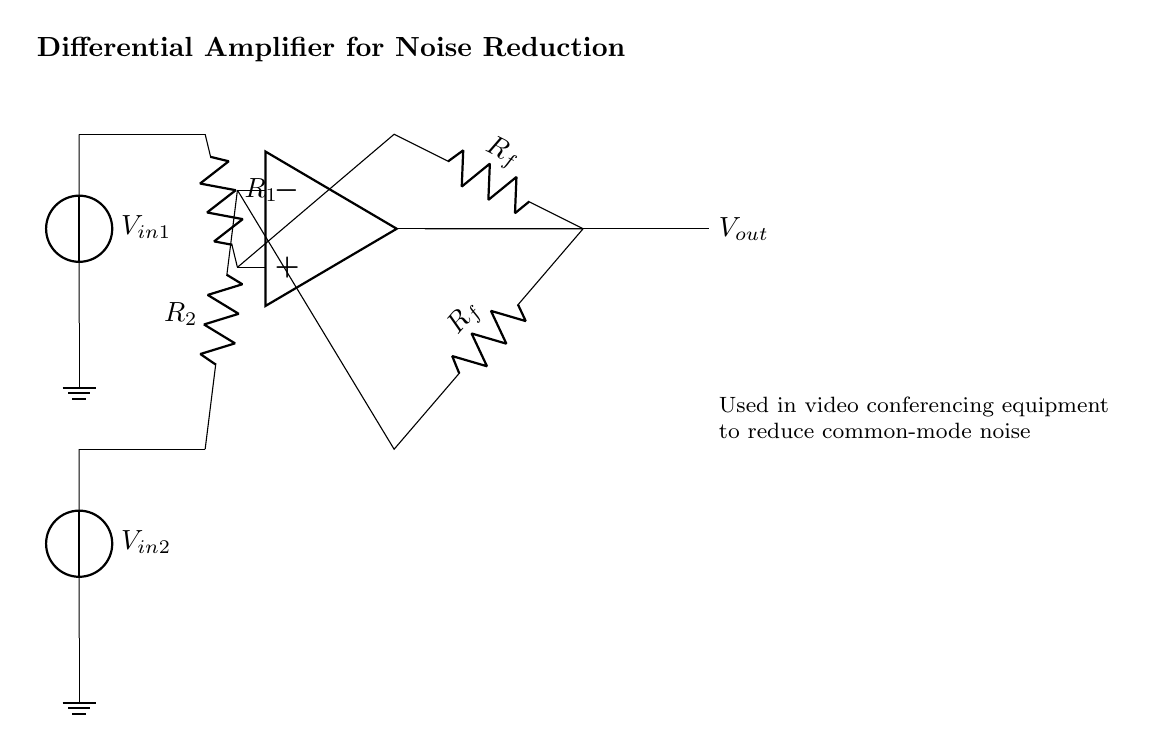What type of amplifier is shown in the diagram? The diagram represents a differential amplifier, which is used to amplify the difference between two input voltages. It is indicated by the op-amp symbol and its configuration connecting two input voltage sources.
Answer: differential amplifier How many input voltage sources are there? The circuit has two input voltage sources, labeled as V in one and V in two, connected to the non-inverting and inverting terminals of the op-amp. This indicates it is designed to process two signals simultaneously.
Answer: two What are the values of R1 and R2? The diagram does not specify numerical values for R1 and R2, only their role as resistors in conjunction with the respective input voltages. Their function is to affect the gain of the amplifier based on their resistance values.
Answer: not specified What is the purpose of the feedback resistor Rf? The feedback resistor Rf is crucial as it determines the gain of the differential amplifier by feeding some of the output voltage back to the inverting terminal, allowing for stable amplification of the differential signal.
Answer: gain stabilization Which component reduces common-mode noise? The differential amplifier configuration itself, utilizing the two input voltages and resistors, is designed to minimize common-mode noise by amplifying only the difference between V in one and V in two, effectively rejecting signals that are present in both.
Answer: differential amplifier What is the output voltage denoted as? The output voltage is marked as V out in the diagram, indicating the amplified output signal derived from the differential operation performed by the op-amp given its input voltages.
Answer: V out What kind of equipment is this circuit typically used in? This differential amplifier is typically used in video conferencing equipment to enhance the clarity of the audio and reduce noise, which is essential for effective communication during calls.
Answer: video conferencing equipment 